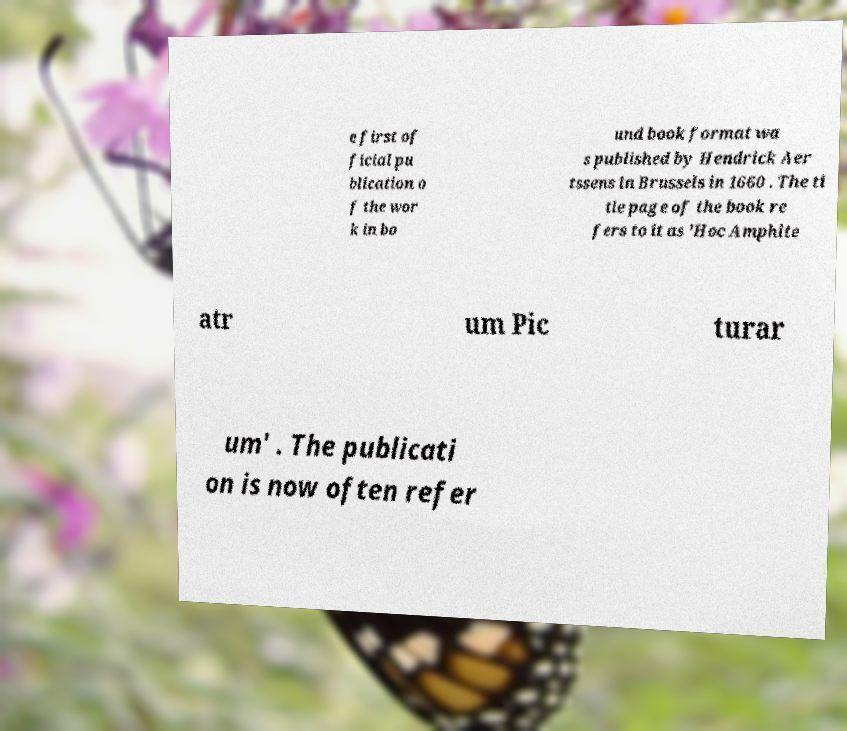I need the written content from this picture converted into text. Can you do that? e first of ficial pu blication o f the wor k in bo und book format wa s published by Hendrick Aer tssens in Brussels in 1660 . The ti tle page of the book re fers to it as 'Hoc Amphite atr um Pic turar um' . The publicati on is now often refer 